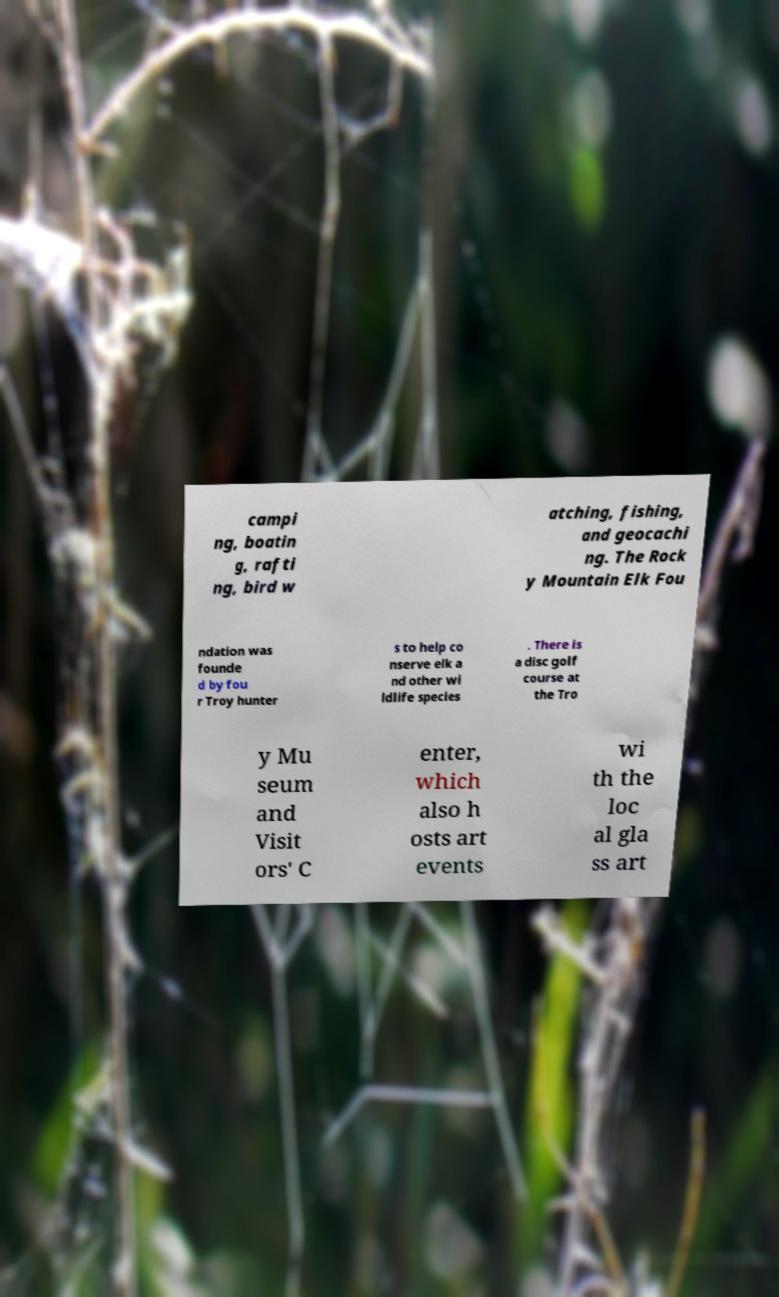Could you assist in decoding the text presented in this image and type it out clearly? campi ng, boatin g, rafti ng, bird w atching, fishing, and geocachi ng. The Rock y Mountain Elk Fou ndation was founde d by fou r Troy hunter s to help co nserve elk a nd other wi ldlife species . There is a disc golf course at the Tro y Mu seum and Visit ors' C enter, which also h osts art events wi th the loc al gla ss art 